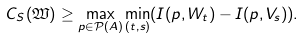<formula> <loc_0><loc_0><loc_500><loc_500>C _ { S } ( \mathfrak { W } ) \geq \max _ { p \in \mathcal { P } ( A ) } \min _ { ( t , s ) } ( I ( p , W _ { t } ) - I ( p , V _ { s } ) ) .</formula> 